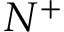Convert formula to latex. <formula><loc_0><loc_0><loc_500><loc_500>N ^ { + }</formula> 